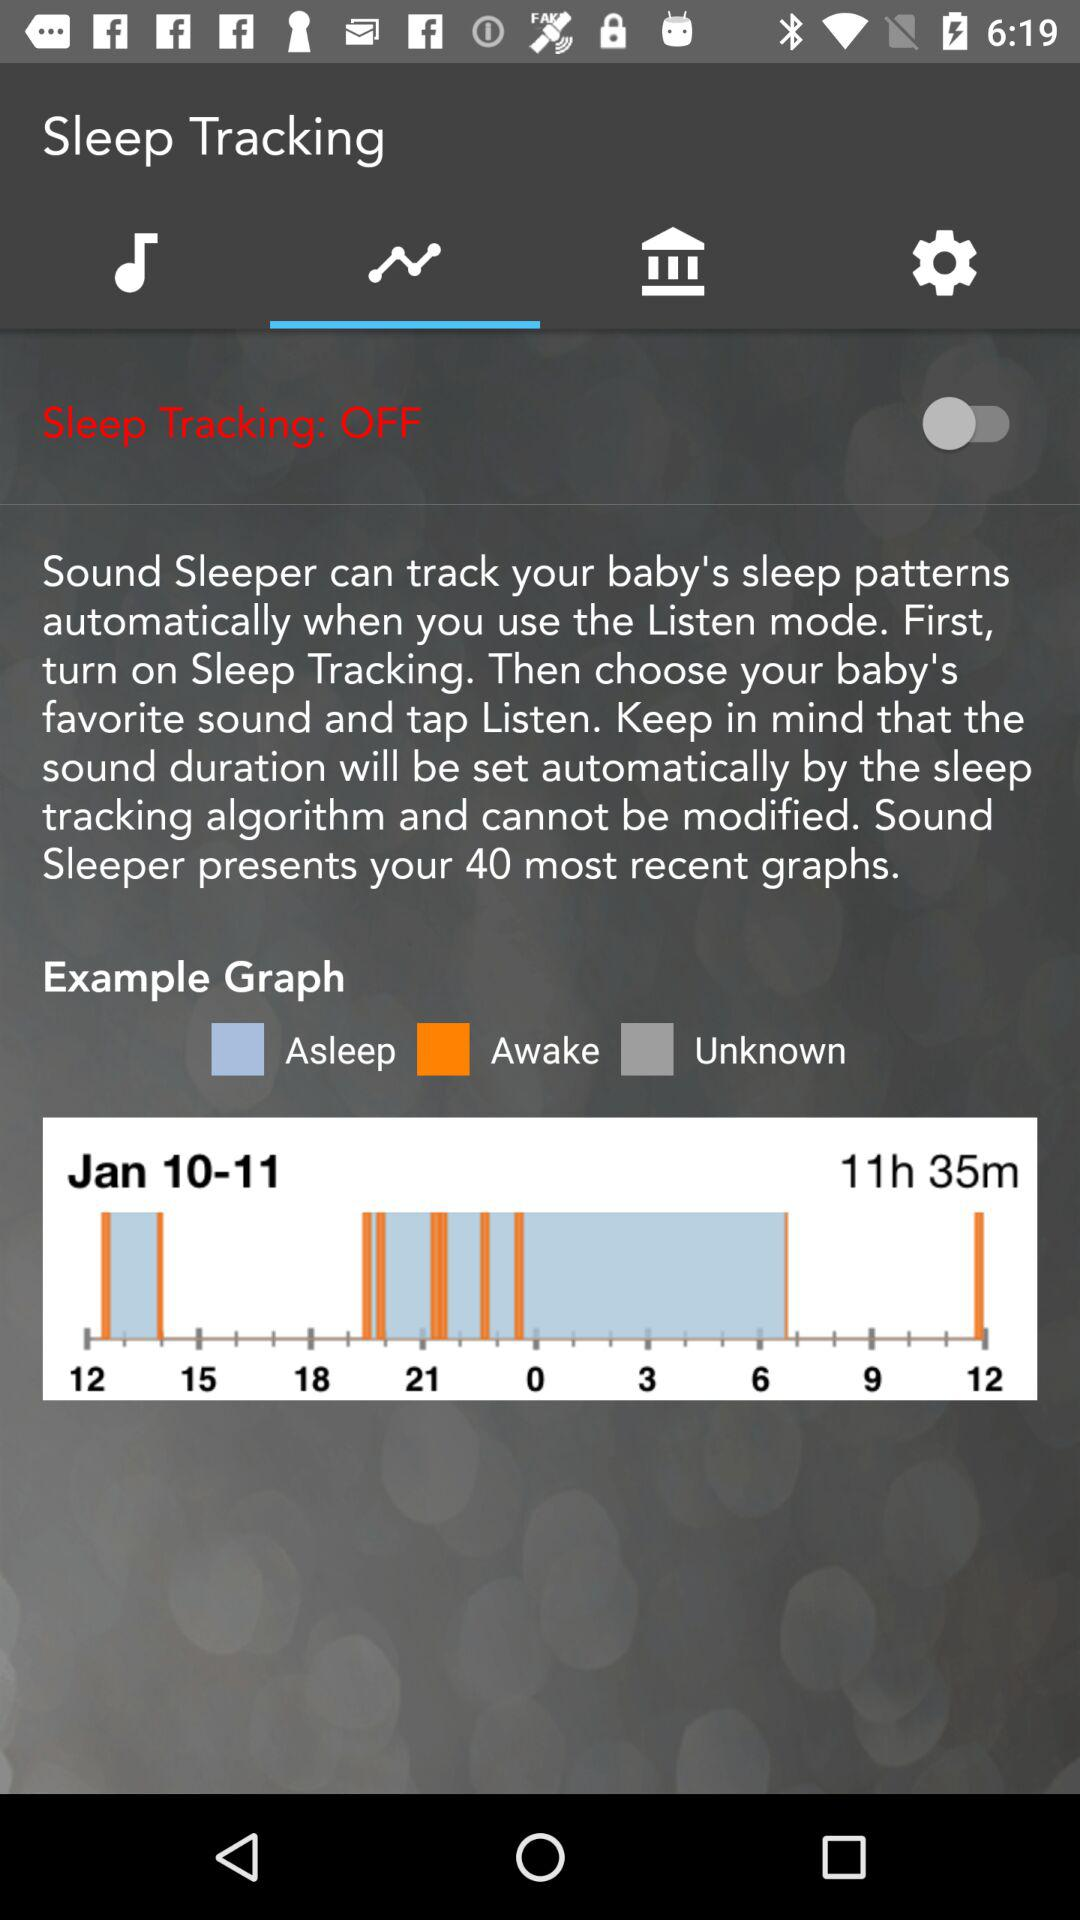What is the duration shown in the graph? The duration shown in the graph is 11 hours and 35 minutes. 